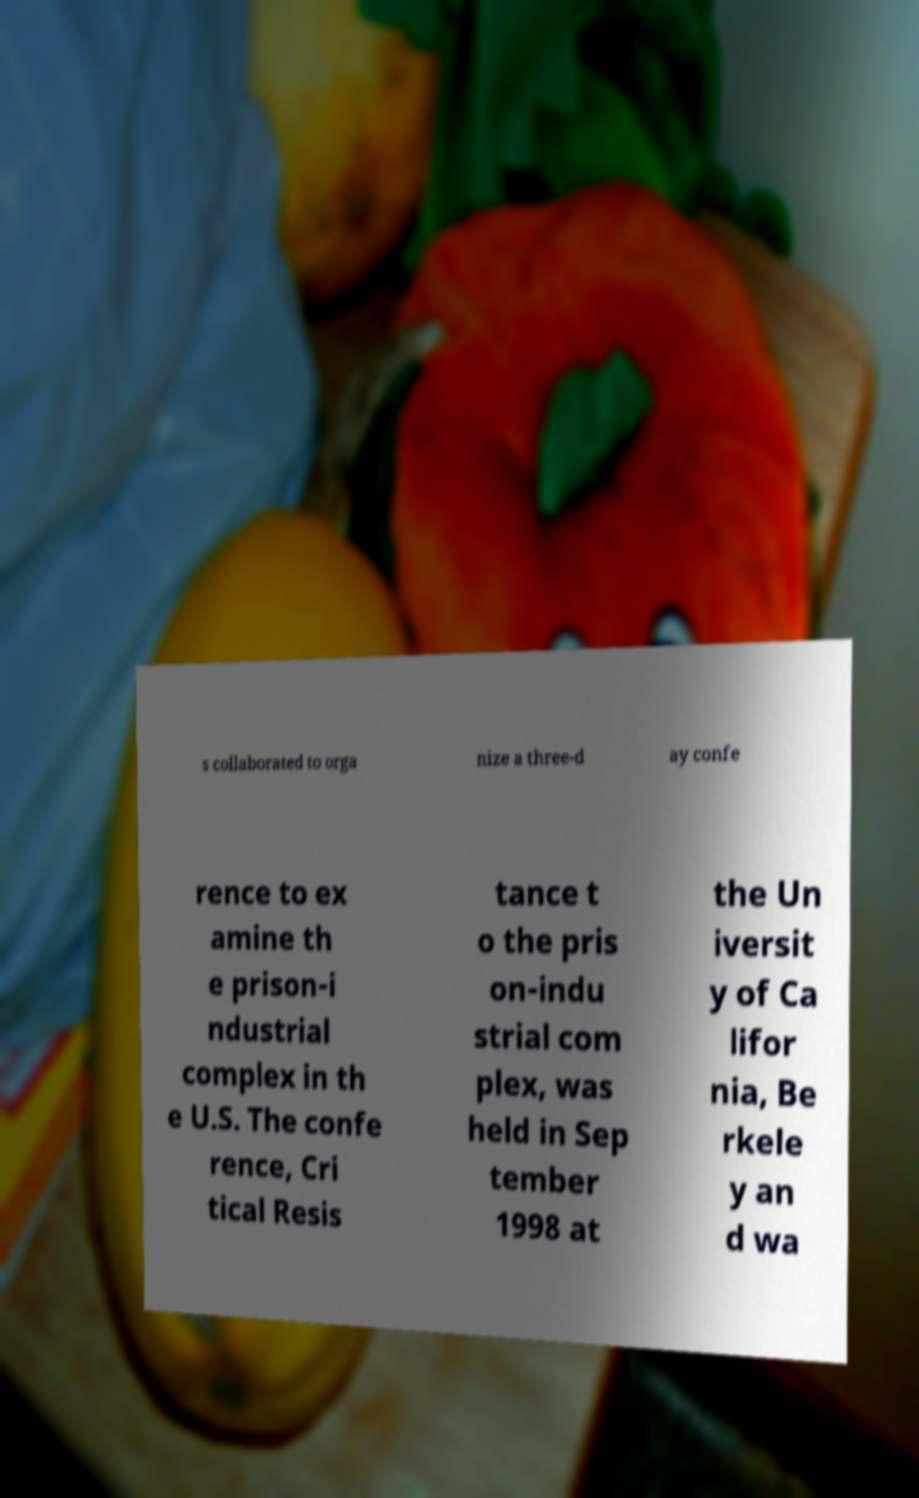Can you accurately transcribe the text from the provided image for me? s collaborated to orga nize a three-d ay confe rence to ex amine th e prison-i ndustrial complex in th e U.S. The confe rence, Cri tical Resis tance t o the pris on-indu strial com plex, was held in Sep tember 1998 at the Un iversit y of Ca lifor nia, Be rkele y an d wa 